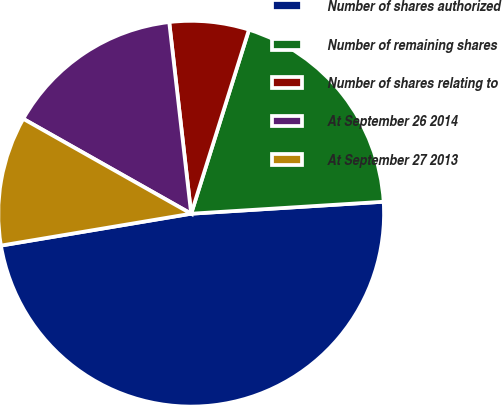Convert chart. <chart><loc_0><loc_0><loc_500><loc_500><pie_chart><fcel>Number of shares authorized<fcel>Number of remaining shares<fcel>Number of shares relating to<fcel>At September 26 2014<fcel>At September 27 2013<nl><fcel>48.35%<fcel>19.17%<fcel>6.66%<fcel>15.0%<fcel>10.83%<nl></chart> 